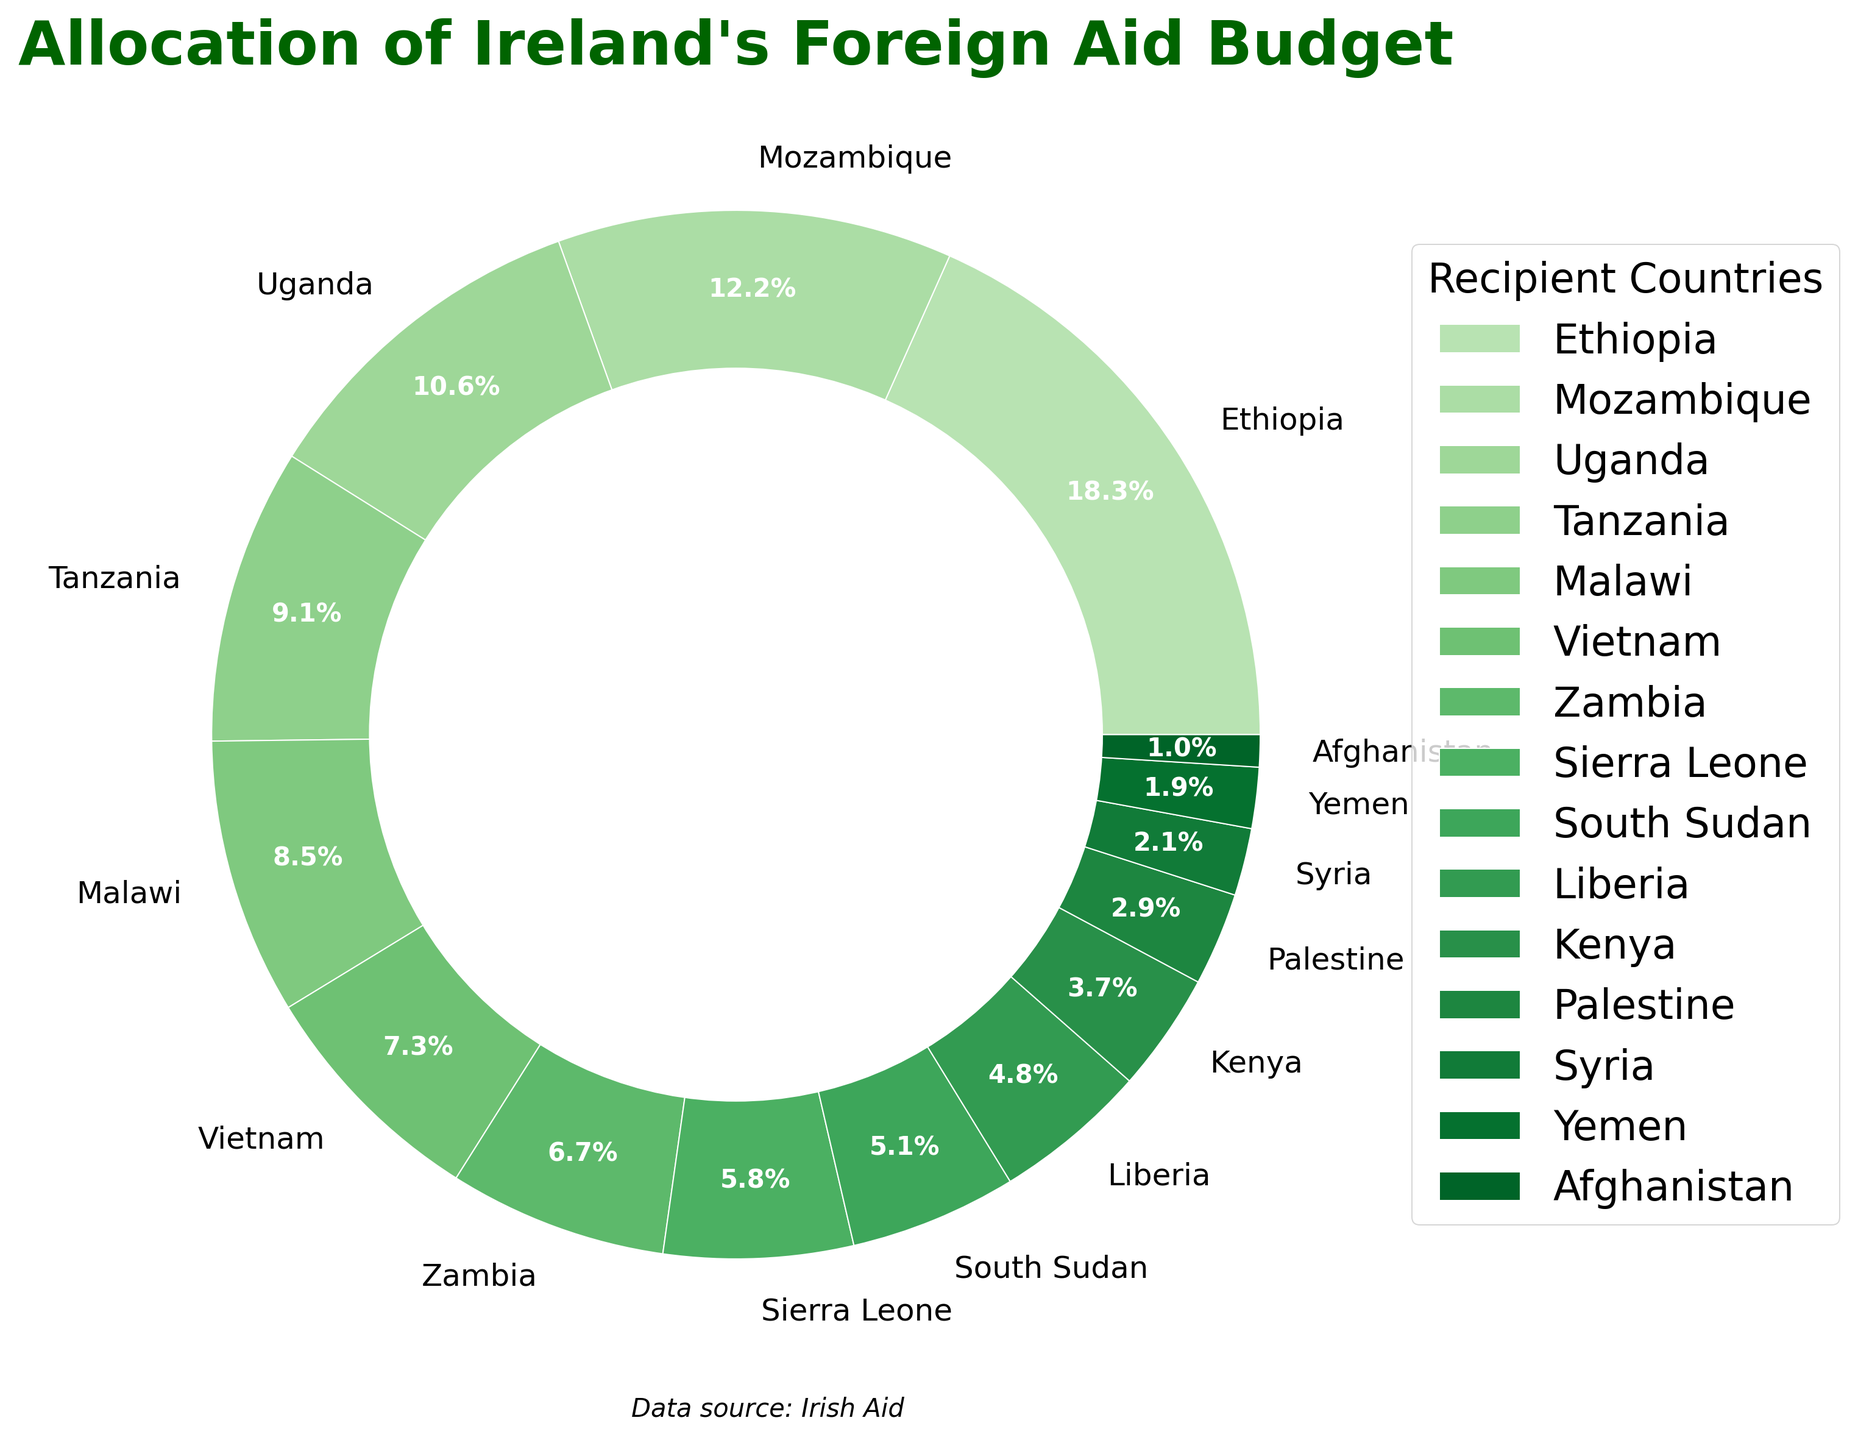What's the sum of the percentages for Ethiopia and Mozambique? Ethiopia has 18.5% and Mozambique has 12.3%. Adding these together is 18.5 + 12.3 = 30.8%.
Answer: 30.8% Which country receives the most significant portion of Ireland's foreign aid budget? By looking at the slices of the pie chart, Ethiopia has the largest wedge compared to others with 18.5%.
Answer: Ethiopia How many countries receive more than 8% of the budget? Identifying the countries with percentages higher than 8%, they are Ethiopia (18.5%), Mozambique (12.3%), Uganda (10.7%), Tanzania (9.2%), and Malawi (8.6%). That totals 5 countries.
Answer: 5 What is the difference in the percentages between Tanzania and Kenya? Tanzania's percentage is 9.2%, and Kenya's percentage is 3.7%. Subtracting Kenya's percentage from Tanzania's, we get 9.2 - 3.7 = 5.5%.
Answer: 5.5% Which has a higher allocation, Palestine or Afghanistan? Comparing the two percentages, Palestine has 2.9% and Afghanistan has 1.0%, so Palestine has a higher allocation.
Answer: Palestine What is the combined allocation percentage for the countries listed from the Middle East (Palestine, Syria, Yemen, Afghanistan)? Palestine has 2.9%, Syria 2.1%, Yemen 1.9%, and Afghanistan 1.0%. Adding these together is 2.9 + 2.1 + 1.9 + 1.0 = 7.9%.
Answer: 7.9% Does Vietnam or Zambia receive a greater share of Ireland's foreign aid? From the chart, Vietnam has 7.4% and Zambia has 6.8%. Vietnam receives a greater share.
Answer: Vietnam Of the countries listed, which receives the smallest percentage of the aid budget? From the pie chart, Afghanistan receives the smallest percentage at 1.0%.
Answer: Afghanistan What is the average percentage received by the top three recipient countries? The top three countries are Ethiopia (18.5%), Mozambique (12.3%), and Uganda (10.7%). Their sum is 18.5 + 12.3 + 10.7 = 41.5. The average then is 41.5 / 3 = 13.83%.
Answer: 13.83% Is the allocation for Malawi higher than the sum of allocations for Yemen and Afghanistan? Malawi has 8.6%, while Yemen has 1.9% and Afghanistan has 1.0%. The sum of Yemen and Afghanistan is 1.9 + 1.0 = 2.9%. Since 8.6% is greater than 2.9%, the answer is yes.
Answer: Yes 